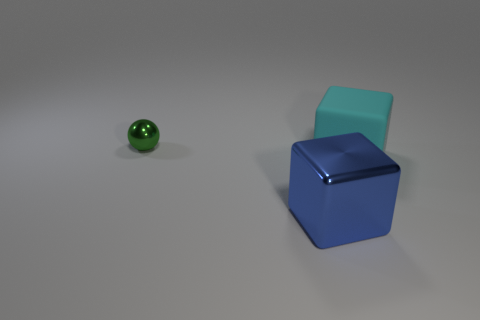Add 1 metallic balls. How many objects exist? 4 Subtract all blocks. How many objects are left? 1 Add 2 large red shiny cylinders. How many large red shiny cylinders exist? 2 Subtract 0 red blocks. How many objects are left? 3 Subtract all small metallic things. Subtract all brown metal objects. How many objects are left? 2 Add 3 cyan rubber cubes. How many cyan rubber cubes are left? 4 